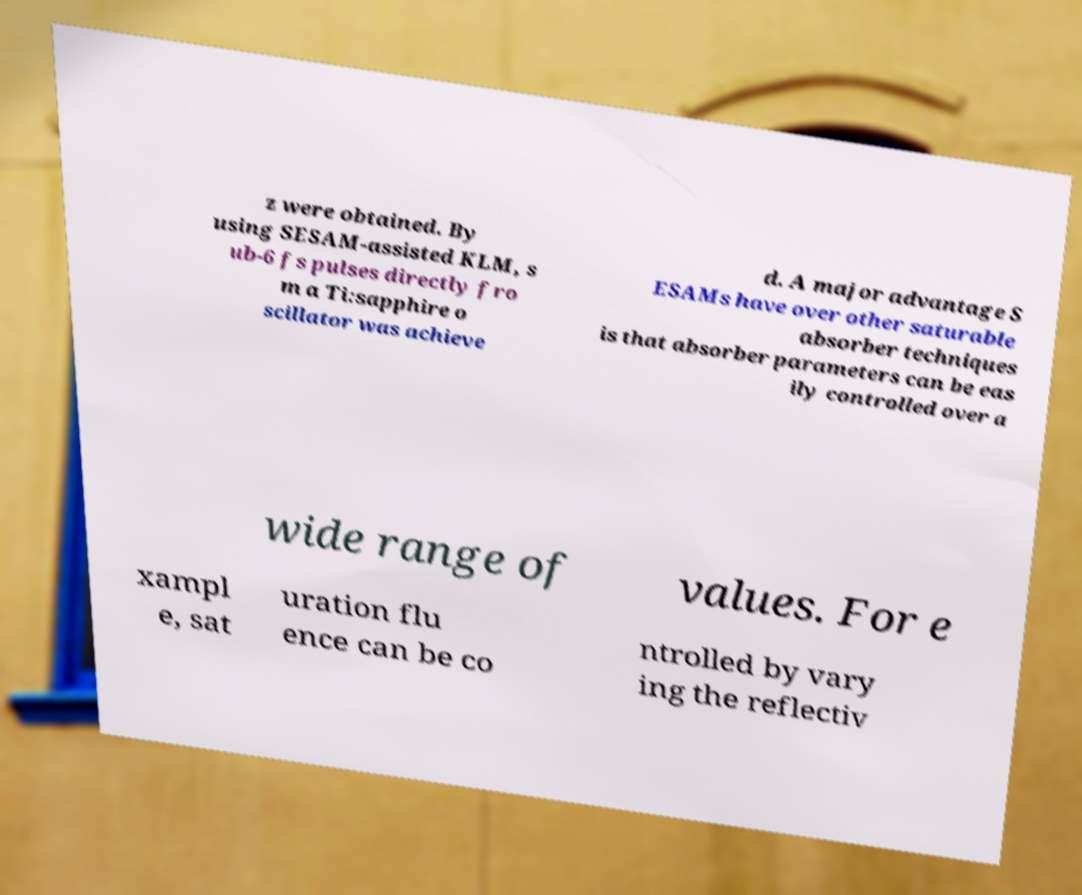Please read and relay the text visible in this image. What does it say? z were obtained. By using SESAM-assisted KLM, s ub-6 fs pulses directly fro m a Ti:sapphire o scillator was achieve d. A major advantage S ESAMs have over other saturable absorber techniques is that absorber parameters can be eas ily controlled over a wide range of values. For e xampl e, sat uration flu ence can be co ntrolled by vary ing the reflectiv 